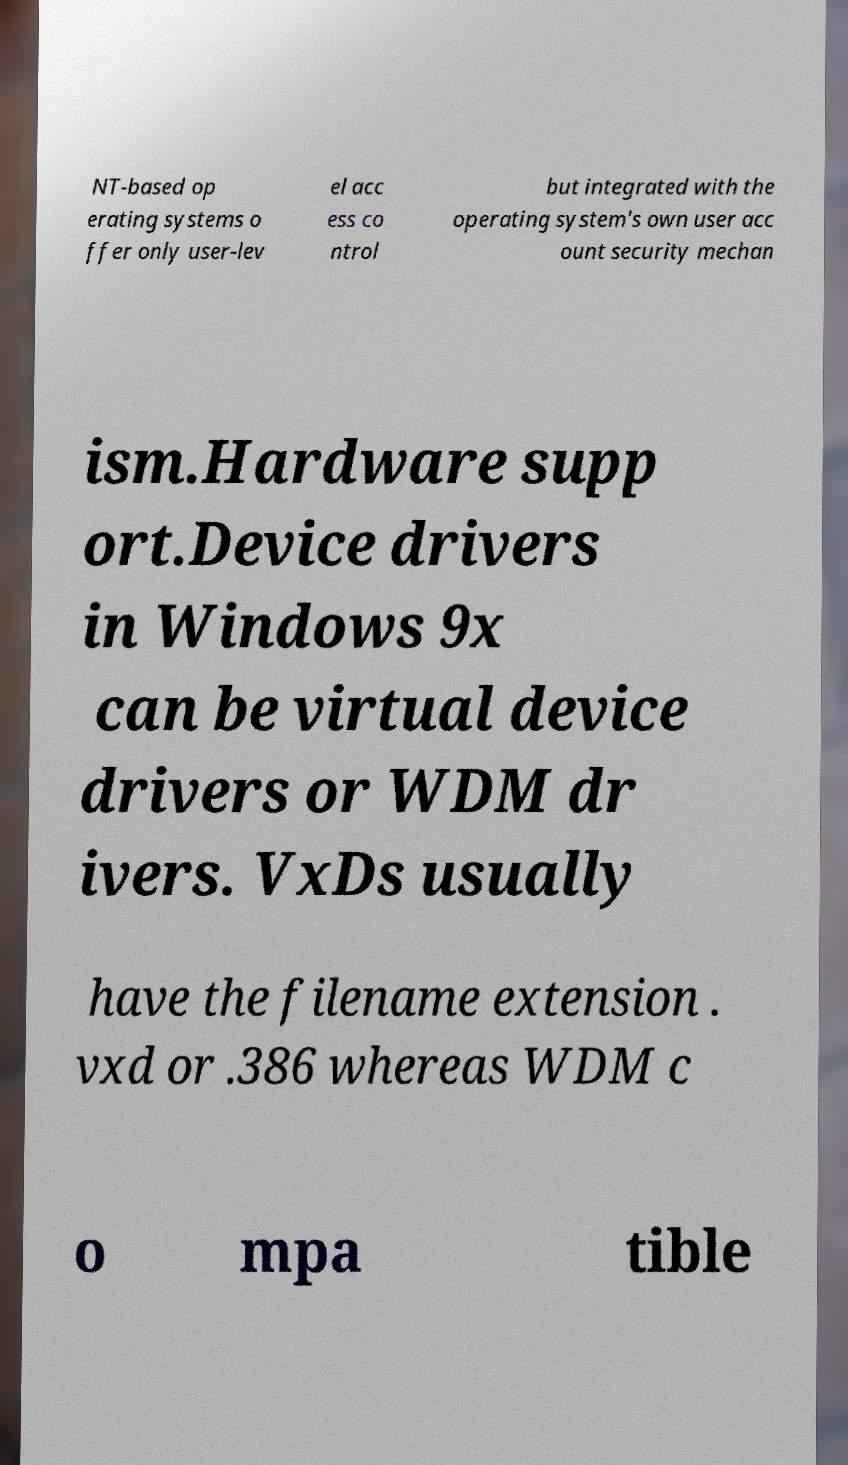Could you assist in decoding the text presented in this image and type it out clearly? NT-based op erating systems o ffer only user-lev el acc ess co ntrol but integrated with the operating system's own user acc ount security mechan ism.Hardware supp ort.Device drivers in Windows 9x can be virtual device drivers or WDM dr ivers. VxDs usually have the filename extension . vxd or .386 whereas WDM c o mpa tible 